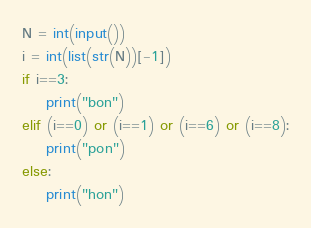<code> <loc_0><loc_0><loc_500><loc_500><_Python_>N = int(input())
i = int(list(str(N))[-1])
if i==3:
    print("bon")
elif (i==0) or (i==1) or (i==6) or (i==8):
    print("pon")
else:
    print("hon")</code> 